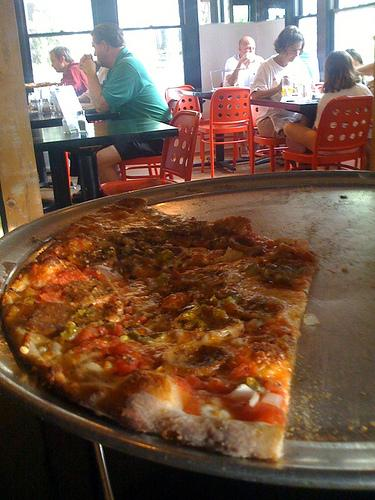What category of pizza would this fall into?

Choices:
A) cheese only
B) hawaiian
C) vegetarian
D) gluten-free vegetarian 